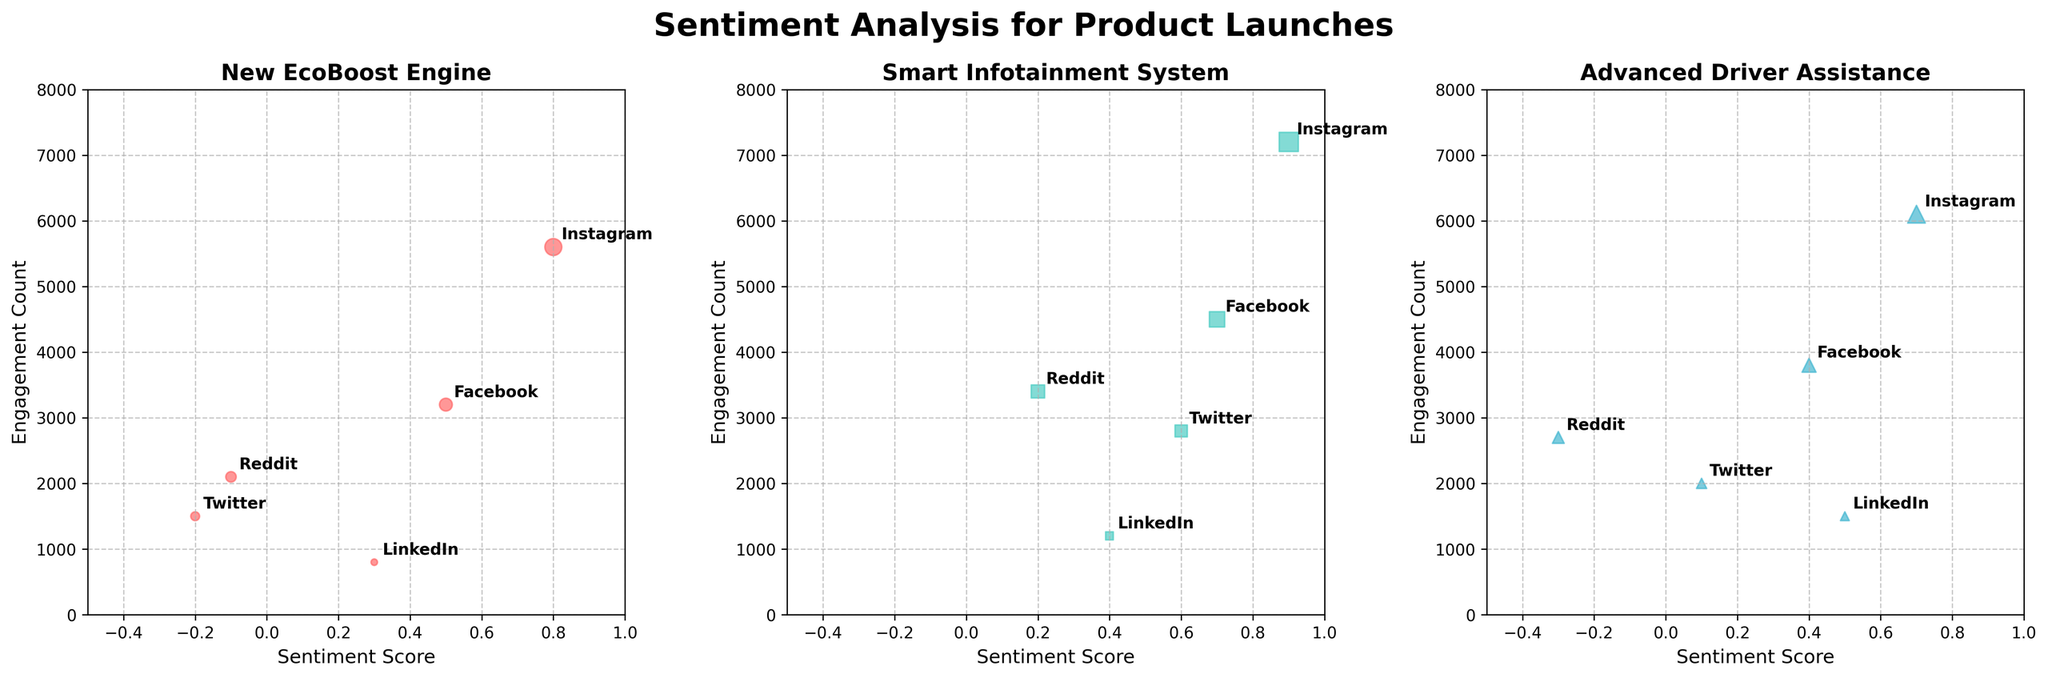Which platform has the highest sentiment score for the "Advanced Driver Assistance"? To find the highest sentiment score for "Advanced Driver Assistance", we check the plot for this product and see that Instagram has the highest sentiment score of 0.7.
Answer: Instagram Which platform has the lowest engagement count for the "New EcoBoost Engine"? By examining the "New EcoBoost Engine" plot, we see that LinkedIn has the lowest engagement count at 800.
Answer: LinkedIn Which product sees the highest engagement count on Instagram? We look at Instagram data points across all three product plots and see that the "Smart Infotainment System" has the highest engagement count at 7200.
Answer: Smart Infotainment System What is the average sentiment score for Twitter across all products? Calculating the average sentiment score for Twitter involves adding the sentiment scores from each product (-0.2, 0.6, 0.1) and dividing by the number of products. (-0.2 + 0.6 + 0.1) / 3 = 0.1667
Answer: 0.17 Which product has the most varied sentiment scores across platforms? To determine the product with the most varied sentiment scores, we look at the range of sentiment scores for each product. The range for "New EcoBoost Engine" is (-0.2 to 0.8), for "Smart Infotainment System" is (0.2 to 0.9), and for "Advanced Driver Assistance" is (-0.3 to 0.7). The "New EcoBoost Engine" has the largest range.
Answer: New EcoBoost Engine Is there any platform consistently showing positive sentiment scores across all products? By checking each platform on the individual product plots, we see that Facebook, Instagram, and LinkedIn show positive sentiment scores across all products, but LinkedIn shows slightly lower scores occasionally. Facebook and Instagram show consistently high positive scores.
Answer: Facebook and Instagram Which platform has the highest engagement count for the "Smart Infotainment System"? By examining the "Smart Infotainment System" plot, we find that Instagram has the highest engagement count at 7200.
Answer: Instagram Which product has received negative sentiment scores from Reddit? To see which products have negative sentiment scores from Reddit, we check the sentiment scores for Reddit. Both "New EcoBoost Engine" (-0.1) and "Advanced Driver Assistance" (-0.3) received negative scores.
Answer: New EcoBoost Engine and Advanced Driver Assistance 